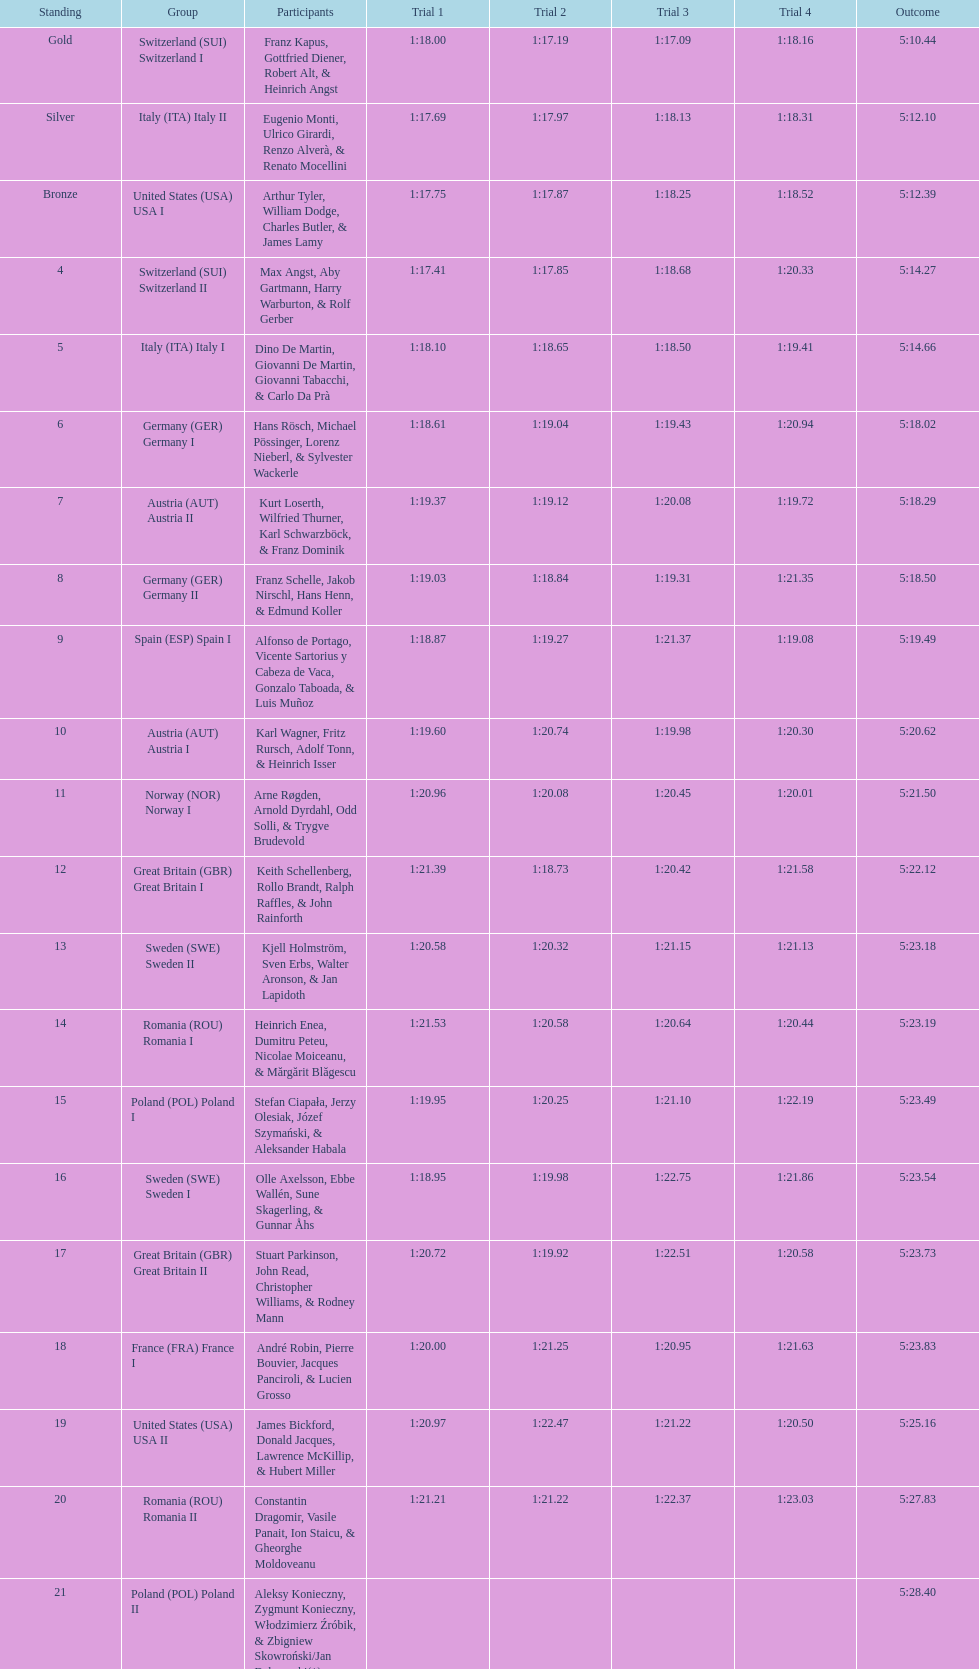Which team had the most time? Poland. 